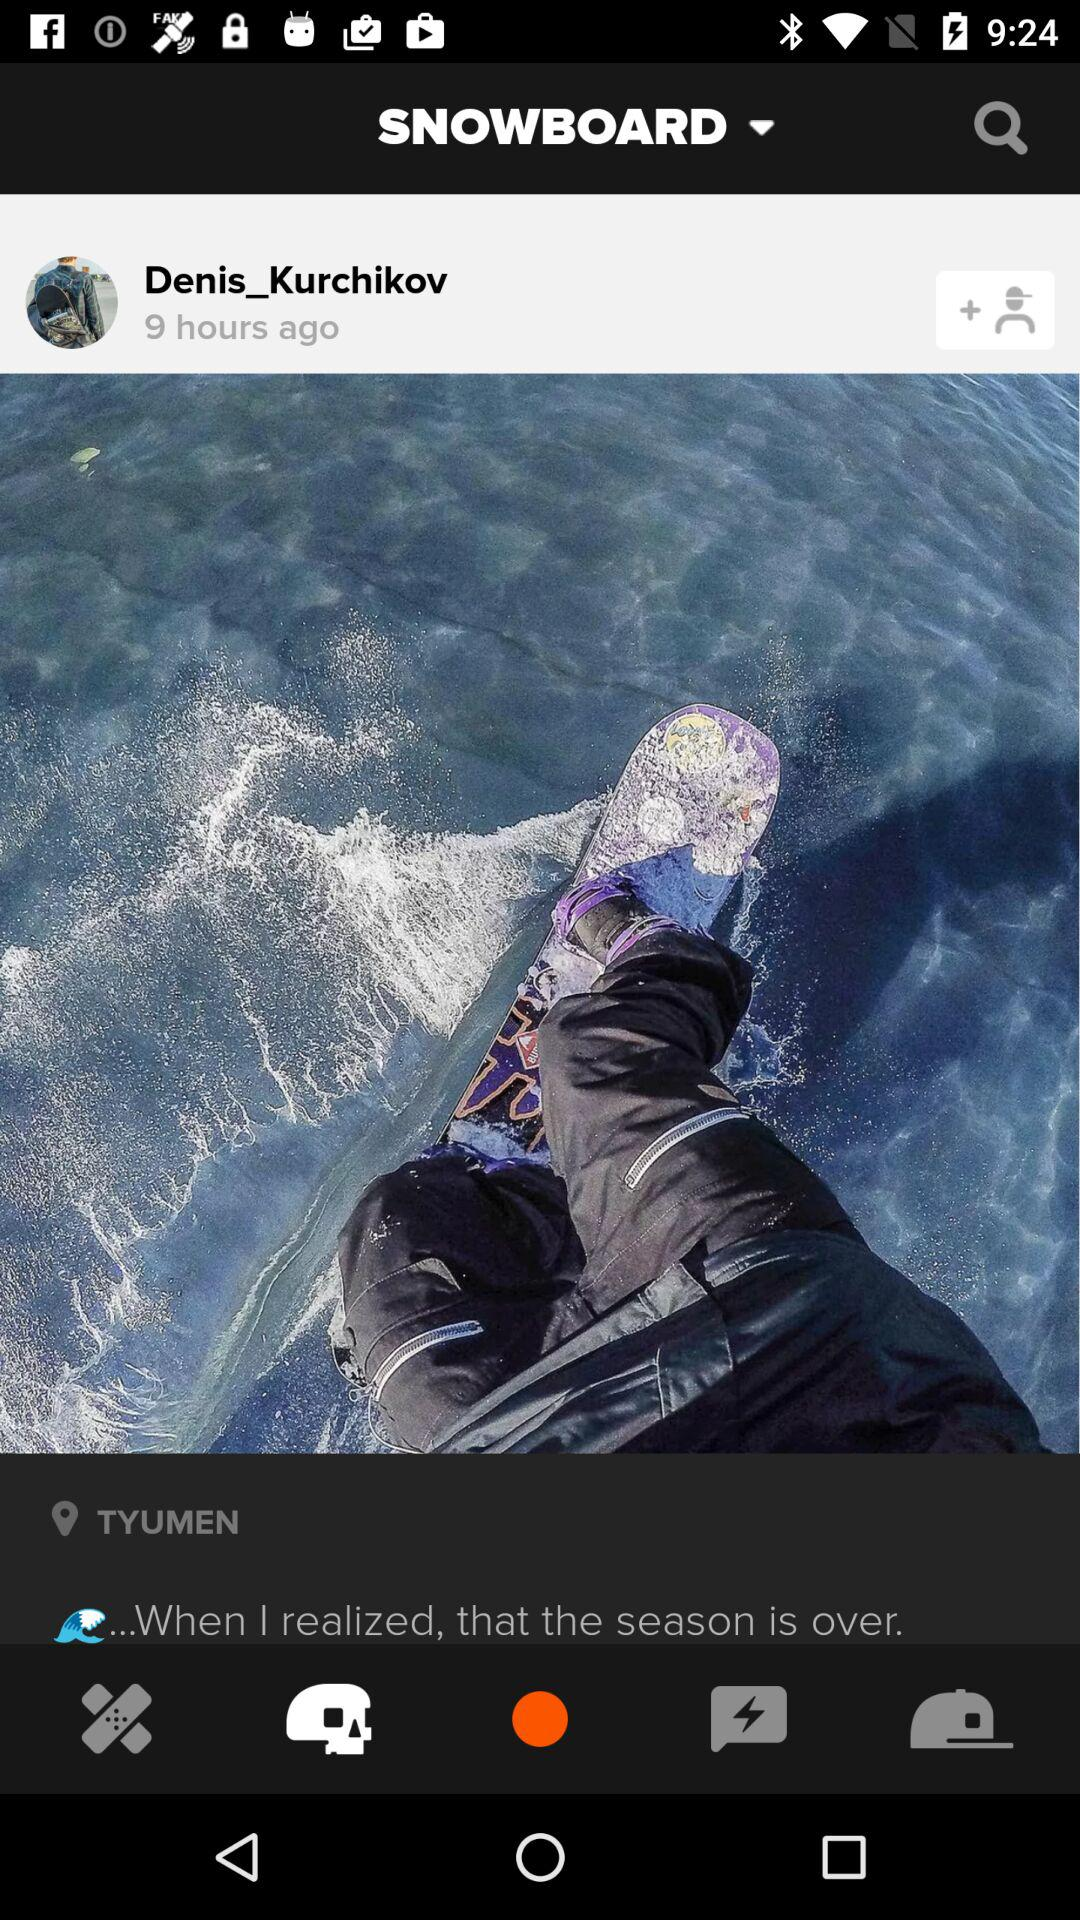How many people are there in the photo?
Answer the question using a single word or phrase. 1 